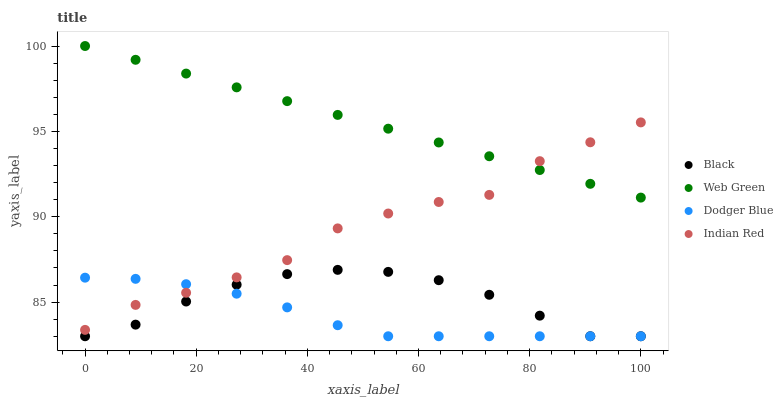Does Dodger Blue have the minimum area under the curve?
Answer yes or no. Yes. Does Web Green have the maximum area under the curve?
Answer yes or no. Yes. Does Black have the minimum area under the curve?
Answer yes or no. No. Does Black have the maximum area under the curve?
Answer yes or no. No. Is Web Green the smoothest?
Answer yes or no. Yes. Is Indian Red the roughest?
Answer yes or no. Yes. Is Black the smoothest?
Answer yes or no. No. Is Black the roughest?
Answer yes or no. No. Does Dodger Blue have the lowest value?
Answer yes or no. Yes. Does Indian Red have the lowest value?
Answer yes or no. No. Does Web Green have the highest value?
Answer yes or no. Yes. Does Black have the highest value?
Answer yes or no. No. Is Black less than Indian Red?
Answer yes or no. Yes. Is Web Green greater than Black?
Answer yes or no. Yes. Does Dodger Blue intersect Black?
Answer yes or no. Yes. Is Dodger Blue less than Black?
Answer yes or no. No. Is Dodger Blue greater than Black?
Answer yes or no. No. Does Black intersect Indian Red?
Answer yes or no. No. 